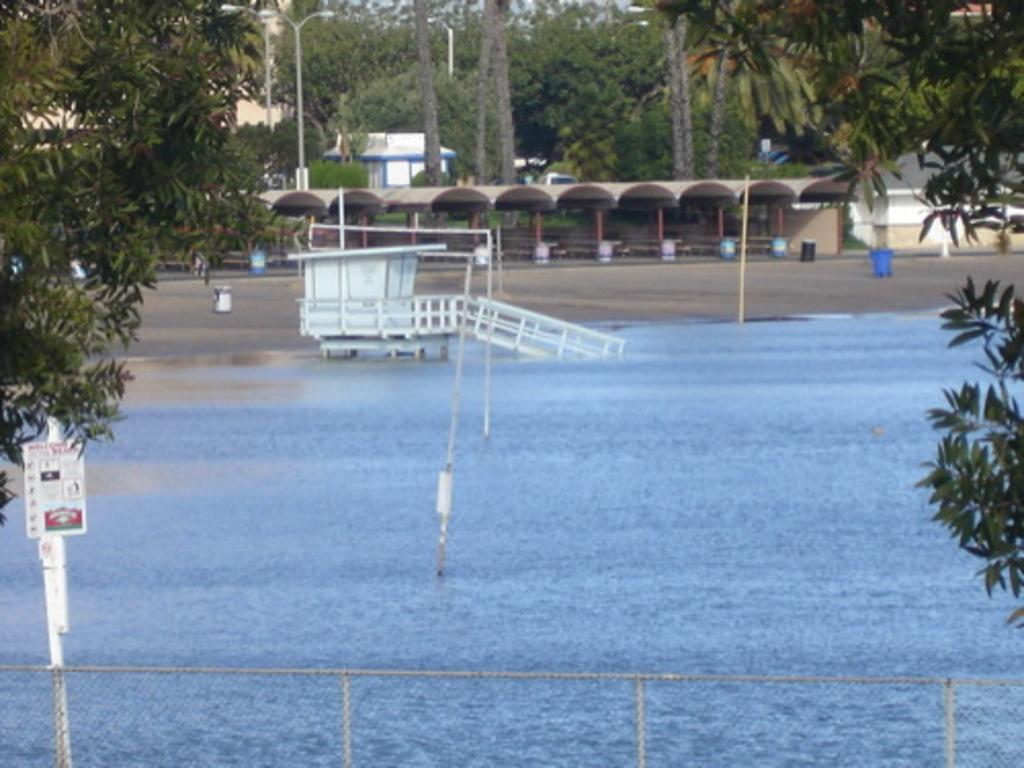What is visible in the image that is related to water? There is water visible in the image. What type of structure can be seen in the image? There is a fence in the image. What type of vegetation is present in the image? There are trees in the image. What type of vertical structures are present in the image? There are poles in the image. What type of shelter is present in the image? There are shelters in the image. Can you describe the unspecified objects in the image? Unfortunately, the facts provided do not specify the nature of the unspecified objects in the image. How many sheets are used to cover the camp in the image? There is no camp or sheets present in the image. What type of camp can be seen in the image? There is no camp present in the image. 